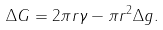Convert formula to latex. <formula><loc_0><loc_0><loc_500><loc_500>\Delta G = 2 \pi r \gamma - \pi r ^ { 2 } \Delta g .</formula> 